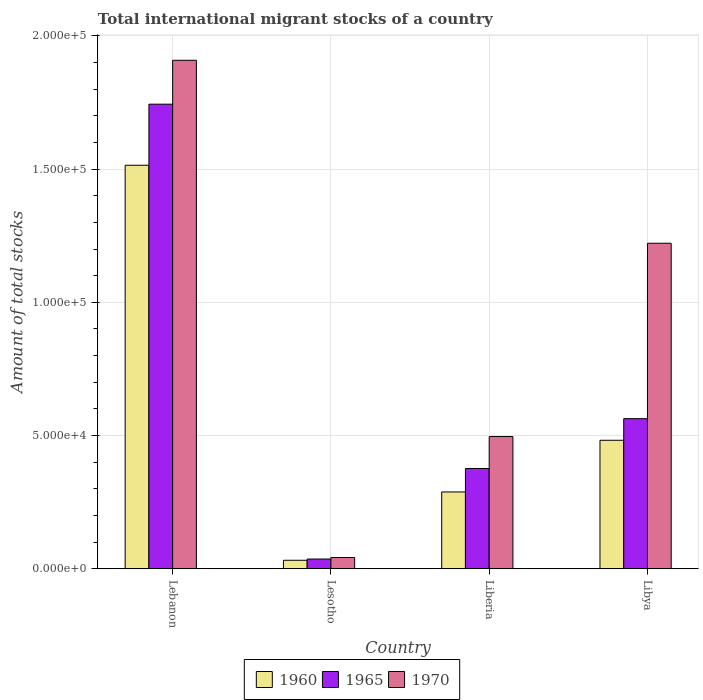How many different coloured bars are there?
Offer a very short reply. 3. How many groups of bars are there?
Keep it short and to the point. 4. Are the number of bars per tick equal to the number of legend labels?
Offer a terse response. Yes. How many bars are there on the 4th tick from the left?
Provide a succinct answer. 3. How many bars are there on the 3rd tick from the right?
Ensure brevity in your answer.  3. What is the label of the 3rd group of bars from the left?
Provide a short and direct response. Liberia. In how many cases, is the number of bars for a given country not equal to the number of legend labels?
Provide a short and direct response. 0. What is the amount of total stocks in in 1965 in Lebanon?
Your response must be concise. 1.74e+05. Across all countries, what is the maximum amount of total stocks in in 1970?
Ensure brevity in your answer.  1.91e+05. Across all countries, what is the minimum amount of total stocks in in 1970?
Ensure brevity in your answer.  4205. In which country was the amount of total stocks in in 1960 maximum?
Your answer should be very brief. Lebanon. In which country was the amount of total stocks in in 1965 minimum?
Make the answer very short. Lesotho. What is the total amount of total stocks in in 1970 in the graph?
Give a very brief answer. 3.67e+05. What is the difference between the amount of total stocks in in 1965 in Lesotho and that in Libya?
Your answer should be very brief. -5.27e+04. What is the difference between the amount of total stocks in in 1965 in Liberia and the amount of total stocks in in 1970 in Libya?
Your answer should be compact. -8.46e+04. What is the average amount of total stocks in in 1970 per country?
Give a very brief answer. 9.17e+04. What is the difference between the amount of total stocks in of/in 1960 and amount of total stocks in of/in 1970 in Liberia?
Offer a very short reply. -2.08e+04. What is the ratio of the amount of total stocks in in 1960 in Lebanon to that in Libya?
Your answer should be very brief. 3.14. Is the amount of total stocks in in 1965 in Lesotho less than that in Liberia?
Your response must be concise. Yes. What is the difference between the highest and the second highest amount of total stocks in in 1965?
Keep it short and to the point. 1.18e+05. What is the difference between the highest and the lowest amount of total stocks in in 1960?
Provide a short and direct response. 1.48e+05. In how many countries, is the amount of total stocks in in 1970 greater than the average amount of total stocks in in 1970 taken over all countries?
Your answer should be very brief. 2. Is the sum of the amount of total stocks in in 1960 in Lebanon and Libya greater than the maximum amount of total stocks in in 1970 across all countries?
Your answer should be compact. Yes. What does the 2nd bar from the left in Lebanon represents?
Offer a very short reply. 1965. What does the 2nd bar from the right in Lebanon represents?
Your response must be concise. 1965. Is it the case that in every country, the sum of the amount of total stocks in in 1970 and amount of total stocks in in 1965 is greater than the amount of total stocks in in 1960?
Offer a very short reply. Yes. How many bars are there?
Provide a succinct answer. 12. How many countries are there in the graph?
Your answer should be very brief. 4. Does the graph contain any zero values?
Make the answer very short. No. How many legend labels are there?
Give a very brief answer. 3. What is the title of the graph?
Your answer should be very brief. Total international migrant stocks of a country. Does "1964" appear as one of the legend labels in the graph?
Keep it short and to the point. No. What is the label or title of the Y-axis?
Ensure brevity in your answer.  Amount of total stocks. What is the Amount of total stocks of 1960 in Lebanon?
Provide a succinct answer. 1.51e+05. What is the Amount of total stocks of 1965 in Lebanon?
Your answer should be compact. 1.74e+05. What is the Amount of total stocks of 1970 in Lebanon?
Offer a very short reply. 1.91e+05. What is the Amount of total stocks of 1960 in Lesotho?
Your answer should be compact. 3165. What is the Amount of total stocks of 1965 in Lesotho?
Offer a terse response. 3633. What is the Amount of total stocks of 1970 in Lesotho?
Give a very brief answer. 4205. What is the Amount of total stocks in 1960 in Liberia?
Your answer should be compact. 2.88e+04. What is the Amount of total stocks in 1965 in Liberia?
Your answer should be compact. 3.76e+04. What is the Amount of total stocks of 1970 in Liberia?
Ensure brevity in your answer.  4.96e+04. What is the Amount of total stocks of 1960 in Libya?
Your answer should be very brief. 4.82e+04. What is the Amount of total stocks in 1965 in Libya?
Your answer should be compact. 5.63e+04. What is the Amount of total stocks of 1970 in Libya?
Give a very brief answer. 1.22e+05. Across all countries, what is the maximum Amount of total stocks in 1960?
Provide a short and direct response. 1.51e+05. Across all countries, what is the maximum Amount of total stocks of 1965?
Provide a short and direct response. 1.74e+05. Across all countries, what is the maximum Amount of total stocks of 1970?
Your answer should be compact. 1.91e+05. Across all countries, what is the minimum Amount of total stocks of 1960?
Offer a terse response. 3165. Across all countries, what is the minimum Amount of total stocks in 1965?
Provide a succinct answer. 3633. Across all countries, what is the minimum Amount of total stocks of 1970?
Provide a succinct answer. 4205. What is the total Amount of total stocks in 1960 in the graph?
Ensure brevity in your answer.  2.32e+05. What is the total Amount of total stocks of 1965 in the graph?
Provide a succinct answer. 2.72e+05. What is the total Amount of total stocks in 1970 in the graph?
Give a very brief answer. 3.67e+05. What is the difference between the Amount of total stocks of 1960 in Lebanon and that in Lesotho?
Provide a short and direct response. 1.48e+05. What is the difference between the Amount of total stocks in 1965 in Lebanon and that in Lesotho?
Provide a short and direct response. 1.71e+05. What is the difference between the Amount of total stocks in 1970 in Lebanon and that in Lesotho?
Your response must be concise. 1.87e+05. What is the difference between the Amount of total stocks of 1960 in Lebanon and that in Liberia?
Your answer should be compact. 1.23e+05. What is the difference between the Amount of total stocks of 1965 in Lebanon and that in Liberia?
Offer a terse response. 1.37e+05. What is the difference between the Amount of total stocks in 1970 in Lebanon and that in Liberia?
Your response must be concise. 1.41e+05. What is the difference between the Amount of total stocks in 1960 in Lebanon and that in Libya?
Keep it short and to the point. 1.03e+05. What is the difference between the Amount of total stocks of 1965 in Lebanon and that in Libya?
Give a very brief answer. 1.18e+05. What is the difference between the Amount of total stocks in 1970 in Lebanon and that in Libya?
Give a very brief answer. 6.87e+04. What is the difference between the Amount of total stocks of 1960 in Lesotho and that in Liberia?
Provide a succinct answer. -2.56e+04. What is the difference between the Amount of total stocks in 1965 in Lesotho and that in Liberia?
Make the answer very short. -3.40e+04. What is the difference between the Amount of total stocks in 1970 in Lesotho and that in Liberia?
Provide a succinct answer. -4.54e+04. What is the difference between the Amount of total stocks of 1960 in Lesotho and that in Libya?
Your answer should be compact. -4.50e+04. What is the difference between the Amount of total stocks of 1965 in Lesotho and that in Libya?
Offer a very short reply. -5.27e+04. What is the difference between the Amount of total stocks of 1970 in Lesotho and that in Libya?
Keep it short and to the point. -1.18e+05. What is the difference between the Amount of total stocks in 1960 in Liberia and that in Libya?
Provide a succinct answer. -1.94e+04. What is the difference between the Amount of total stocks in 1965 in Liberia and that in Libya?
Offer a terse response. -1.87e+04. What is the difference between the Amount of total stocks in 1970 in Liberia and that in Libya?
Your answer should be very brief. -7.26e+04. What is the difference between the Amount of total stocks in 1960 in Lebanon and the Amount of total stocks in 1965 in Lesotho?
Keep it short and to the point. 1.48e+05. What is the difference between the Amount of total stocks of 1960 in Lebanon and the Amount of total stocks of 1970 in Lesotho?
Your answer should be compact. 1.47e+05. What is the difference between the Amount of total stocks of 1965 in Lebanon and the Amount of total stocks of 1970 in Lesotho?
Provide a short and direct response. 1.70e+05. What is the difference between the Amount of total stocks of 1960 in Lebanon and the Amount of total stocks of 1965 in Liberia?
Your response must be concise. 1.14e+05. What is the difference between the Amount of total stocks of 1960 in Lebanon and the Amount of total stocks of 1970 in Liberia?
Offer a terse response. 1.02e+05. What is the difference between the Amount of total stocks of 1965 in Lebanon and the Amount of total stocks of 1970 in Liberia?
Provide a succinct answer. 1.25e+05. What is the difference between the Amount of total stocks of 1960 in Lebanon and the Amount of total stocks of 1965 in Libya?
Keep it short and to the point. 9.51e+04. What is the difference between the Amount of total stocks of 1960 in Lebanon and the Amount of total stocks of 1970 in Libya?
Make the answer very short. 2.93e+04. What is the difference between the Amount of total stocks of 1965 in Lebanon and the Amount of total stocks of 1970 in Libya?
Provide a succinct answer. 5.22e+04. What is the difference between the Amount of total stocks in 1960 in Lesotho and the Amount of total stocks in 1965 in Liberia?
Give a very brief answer. -3.44e+04. What is the difference between the Amount of total stocks of 1960 in Lesotho and the Amount of total stocks of 1970 in Liberia?
Your answer should be very brief. -4.64e+04. What is the difference between the Amount of total stocks of 1965 in Lesotho and the Amount of total stocks of 1970 in Liberia?
Your answer should be compact. -4.60e+04. What is the difference between the Amount of total stocks in 1960 in Lesotho and the Amount of total stocks in 1965 in Libya?
Provide a short and direct response. -5.32e+04. What is the difference between the Amount of total stocks in 1960 in Lesotho and the Amount of total stocks in 1970 in Libya?
Your answer should be compact. -1.19e+05. What is the difference between the Amount of total stocks of 1965 in Lesotho and the Amount of total stocks of 1970 in Libya?
Provide a succinct answer. -1.19e+05. What is the difference between the Amount of total stocks of 1960 in Liberia and the Amount of total stocks of 1965 in Libya?
Provide a short and direct response. -2.75e+04. What is the difference between the Amount of total stocks of 1960 in Liberia and the Amount of total stocks of 1970 in Libya?
Keep it short and to the point. -9.34e+04. What is the difference between the Amount of total stocks in 1965 in Liberia and the Amount of total stocks in 1970 in Libya?
Offer a very short reply. -8.46e+04. What is the average Amount of total stocks of 1960 per country?
Your answer should be very brief. 5.79e+04. What is the average Amount of total stocks of 1965 per country?
Provide a succinct answer. 6.80e+04. What is the average Amount of total stocks in 1970 per country?
Make the answer very short. 9.17e+04. What is the difference between the Amount of total stocks of 1960 and Amount of total stocks of 1965 in Lebanon?
Provide a succinct answer. -2.29e+04. What is the difference between the Amount of total stocks of 1960 and Amount of total stocks of 1970 in Lebanon?
Provide a succinct answer. -3.94e+04. What is the difference between the Amount of total stocks in 1965 and Amount of total stocks in 1970 in Lebanon?
Your answer should be very brief. -1.65e+04. What is the difference between the Amount of total stocks in 1960 and Amount of total stocks in 1965 in Lesotho?
Offer a very short reply. -468. What is the difference between the Amount of total stocks of 1960 and Amount of total stocks of 1970 in Lesotho?
Offer a very short reply. -1040. What is the difference between the Amount of total stocks of 1965 and Amount of total stocks of 1970 in Lesotho?
Make the answer very short. -572. What is the difference between the Amount of total stocks in 1960 and Amount of total stocks in 1965 in Liberia?
Give a very brief answer. -8803. What is the difference between the Amount of total stocks of 1960 and Amount of total stocks of 1970 in Liberia?
Ensure brevity in your answer.  -2.08e+04. What is the difference between the Amount of total stocks in 1965 and Amount of total stocks in 1970 in Liberia?
Offer a very short reply. -1.20e+04. What is the difference between the Amount of total stocks of 1960 and Amount of total stocks of 1965 in Libya?
Ensure brevity in your answer.  -8110. What is the difference between the Amount of total stocks of 1960 and Amount of total stocks of 1970 in Libya?
Offer a terse response. -7.40e+04. What is the difference between the Amount of total stocks of 1965 and Amount of total stocks of 1970 in Libya?
Provide a succinct answer. -6.58e+04. What is the ratio of the Amount of total stocks of 1960 in Lebanon to that in Lesotho?
Offer a very short reply. 47.85. What is the ratio of the Amount of total stocks of 1965 in Lebanon to that in Lesotho?
Provide a short and direct response. 48. What is the ratio of the Amount of total stocks in 1970 in Lebanon to that in Lesotho?
Keep it short and to the point. 45.38. What is the ratio of the Amount of total stocks in 1960 in Lebanon to that in Liberia?
Provide a succinct answer. 5.26. What is the ratio of the Amount of total stocks of 1965 in Lebanon to that in Liberia?
Give a very brief answer. 4.64. What is the ratio of the Amount of total stocks of 1970 in Lebanon to that in Liberia?
Offer a very short reply. 3.85. What is the ratio of the Amount of total stocks of 1960 in Lebanon to that in Libya?
Your response must be concise. 3.14. What is the ratio of the Amount of total stocks of 1965 in Lebanon to that in Libya?
Keep it short and to the point. 3.1. What is the ratio of the Amount of total stocks of 1970 in Lebanon to that in Libya?
Keep it short and to the point. 1.56. What is the ratio of the Amount of total stocks in 1960 in Lesotho to that in Liberia?
Make the answer very short. 0.11. What is the ratio of the Amount of total stocks in 1965 in Lesotho to that in Liberia?
Offer a terse response. 0.1. What is the ratio of the Amount of total stocks in 1970 in Lesotho to that in Liberia?
Your answer should be very brief. 0.08. What is the ratio of the Amount of total stocks of 1960 in Lesotho to that in Libya?
Offer a terse response. 0.07. What is the ratio of the Amount of total stocks in 1965 in Lesotho to that in Libya?
Your response must be concise. 0.06. What is the ratio of the Amount of total stocks in 1970 in Lesotho to that in Libya?
Offer a terse response. 0.03. What is the ratio of the Amount of total stocks of 1960 in Liberia to that in Libya?
Provide a succinct answer. 0.6. What is the ratio of the Amount of total stocks in 1965 in Liberia to that in Libya?
Offer a very short reply. 0.67. What is the ratio of the Amount of total stocks in 1970 in Liberia to that in Libya?
Ensure brevity in your answer.  0.41. What is the difference between the highest and the second highest Amount of total stocks of 1960?
Ensure brevity in your answer.  1.03e+05. What is the difference between the highest and the second highest Amount of total stocks of 1965?
Provide a succinct answer. 1.18e+05. What is the difference between the highest and the second highest Amount of total stocks of 1970?
Your response must be concise. 6.87e+04. What is the difference between the highest and the lowest Amount of total stocks in 1960?
Give a very brief answer. 1.48e+05. What is the difference between the highest and the lowest Amount of total stocks in 1965?
Provide a short and direct response. 1.71e+05. What is the difference between the highest and the lowest Amount of total stocks in 1970?
Offer a very short reply. 1.87e+05. 